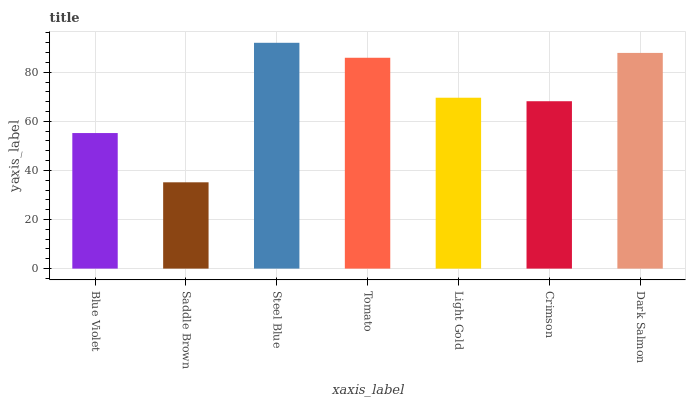Is Saddle Brown the minimum?
Answer yes or no. Yes. Is Steel Blue the maximum?
Answer yes or no. Yes. Is Steel Blue the minimum?
Answer yes or no. No. Is Saddle Brown the maximum?
Answer yes or no. No. Is Steel Blue greater than Saddle Brown?
Answer yes or no. Yes. Is Saddle Brown less than Steel Blue?
Answer yes or no. Yes. Is Saddle Brown greater than Steel Blue?
Answer yes or no. No. Is Steel Blue less than Saddle Brown?
Answer yes or no. No. Is Light Gold the high median?
Answer yes or no. Yes. Is Light Gold the low median?
Answer yes or no. Yes. Is Dark Salmon the high median?
Answer yes or no. No. Is Saddle Brown the low median?
Answer yes or no. No. 